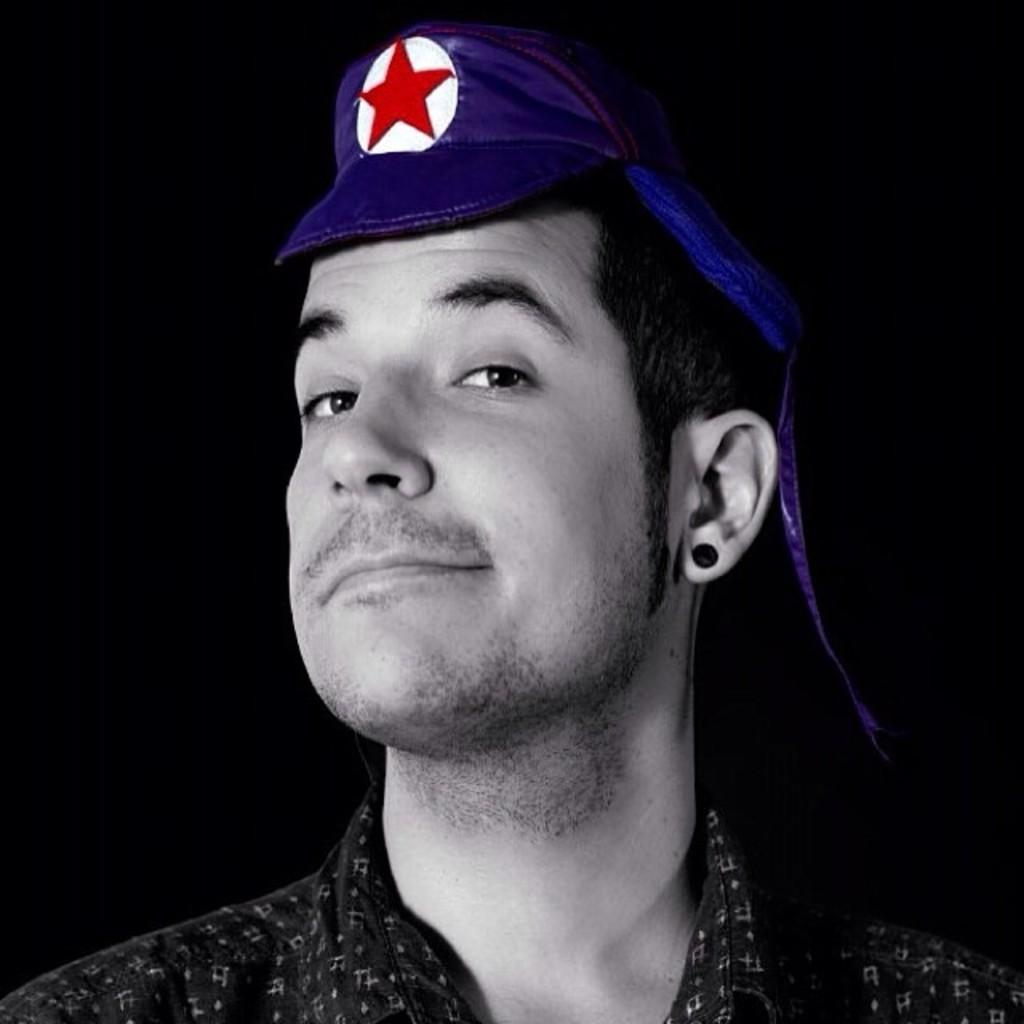What is present in the image? There is a man in the image. Can you describe the man's attire? The man is wearing a cap. What type of art is the man creating in the image? There is no indication in the image that the man is creating any art. 